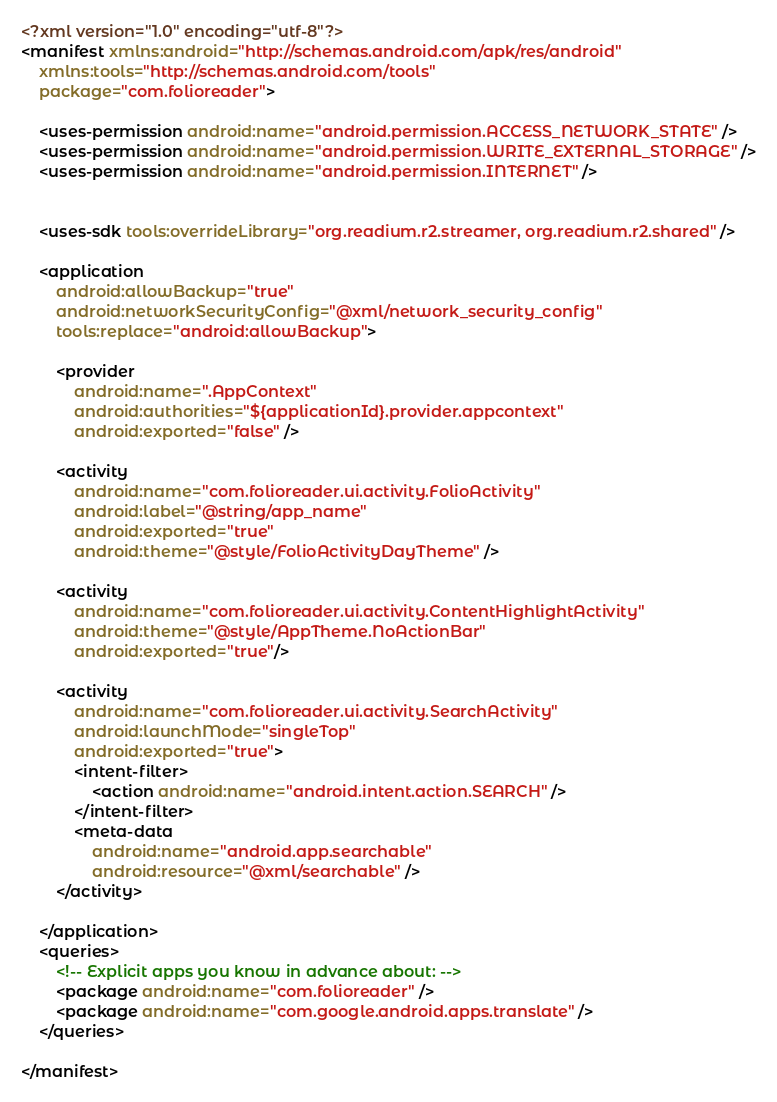Convert code to text. <code><loc_0><loc_0><loc_500><loc_500><_XML_><?xml version="1.0" encoding="utf-8"?>
<manifest xmlns:android="http://schemas.android.com/apk/res/android"
    xmlns:tools="http://schemas.android.com/tools"
    package="com.folioreader">

    <uses-permission android:name="android.permission.ACCESS_NETWORK_STATE" />
    <uses-permission android:name="android.permission.WRITE_EXTERNAL_STORAGE" />
    <uses-permission android:name="android.permission.INTERNET" />


    <uses-sdk tools:overrideLibrary="org.readium.r2.streamer, org.readium.r2.shared" />

    <application
        android:allowBackup="true"
        android:networkSecurityConfig="@xml/network_security_config"
        tools:replace="android:allowBackup">

        <provider
            android:name=".AppContext"
            android:authorities="${applicationId}.provider.appcontext"
            android:exported="false" />

        <activity
            android:name="com.folioreader.ui.activity.FolioActivity"
            android:label="@string/app_name"
            android:exported="true"
            android:theme="@style/FolioActivityDayTheme" />

        <activity
            android:name="com.folioreader.ui.activity.ContentHighlightActivity"
            android:theme="@style/AppTheme.NoActionBar"
            android:exported="true"/>

        <activity
            android:name="com.folioreader.ui.activity.SearchActivity"
            android:launchMode="singleTop"
            android:exported="true">
            <intent-filter>
                <action android:name="android.intent.action.SEARCH" />
            </intent-filter>
            <meta-data
                android:name="android.app.searchable"
                android:resource="@xml/searchable" />
        </activity>

    </application>
    <queries>
        <!-- Explicit apps you know in advance about: -->
        <package android:name="com.folioreader" />
        <package android:name="com.google.android.apps.translate" />
    </queries>

</manifest></code> 